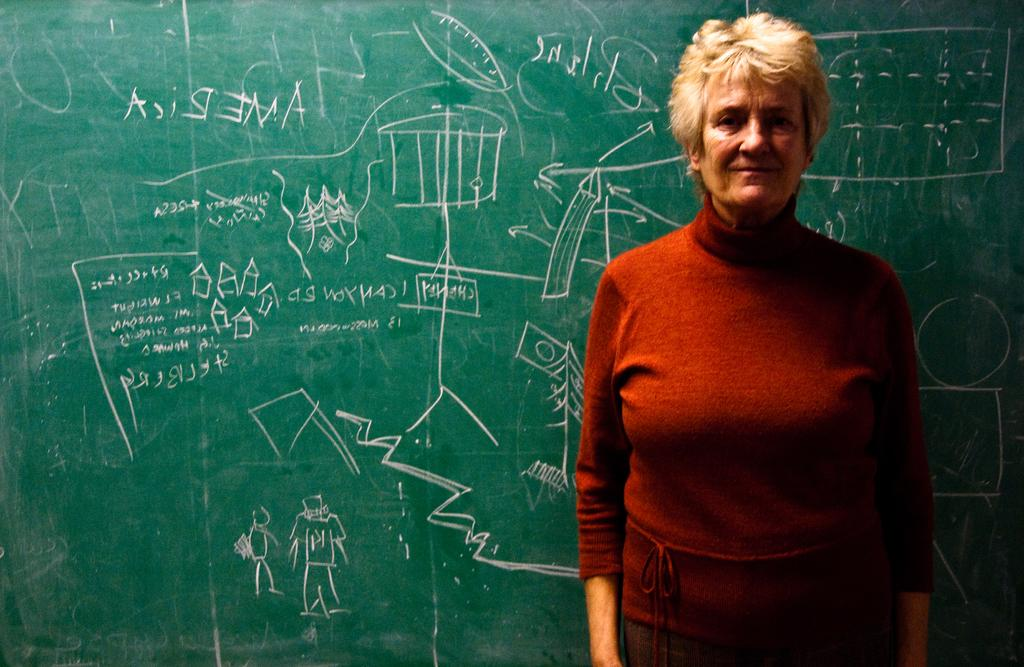Who is present in the image? There is a woman in the image. What is the woman wearing? The woman is wearing a red top. What is the woman's posture in the image? The woman is standing. What can be seen in the background of the image? There is a green board in the background of the image. What is written on the green board? Something is written on the green board. How many people are in the crowd in the image? There is no crowd present in the image; it features a woman standing in front of a green board. What type of cloud can be seen in the image? There are no clouds visible in the image. 